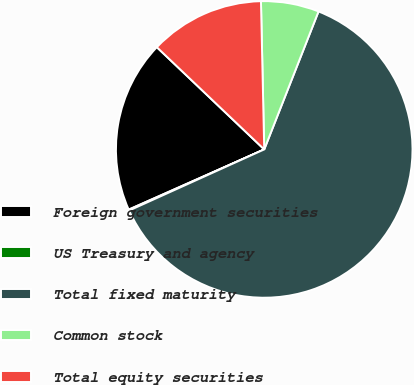Convert chart to OTSL. <chart><loc_0><loc_0><loc_500><loc_500><pie_chart><fcel>Foreign government securities<fcel>US Treasury and agency<fcel>Total fixed maturity<fcel>Common stock<fcel>Total equity securities<nl><fcel>18.76%<fcel>0.11%<fcel>62.27%<fcel>6.32%<fcel>12.54%<nl></chart> 